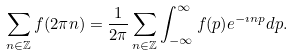<formula> <loc_0><loc_0><loc_500><loc_500>\sum _ { n \in \mathbb { Z } } f ( 2 \pi n ) = \frac { 1 } { 2 \pi } \sum _ { n \in \mathbb { Z } } \int _ { - \infty } ^ { \infty } f ( p ) e ^ { - \imath n p } d p .</formula> 